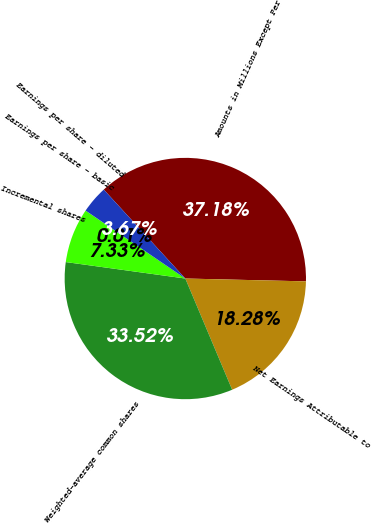Convert chart to OTSL. <chart><loc_0><loc_0><loc_500><loc_500><pie_chart><fcel>Amounts in Millions Except Per<fcel>Net Earnings Attributable to<fcel>Weighted-average common shares<fcel>Incremental shares<fcel>Earnings per share - basic<fcel>Earnings per share - diluted<nl><fcel>37.18%<fcel>18.28%<fcel>33.52%<fcel>7.33%<fcel>0.01%<fcel>3.67%<nl></chart> 